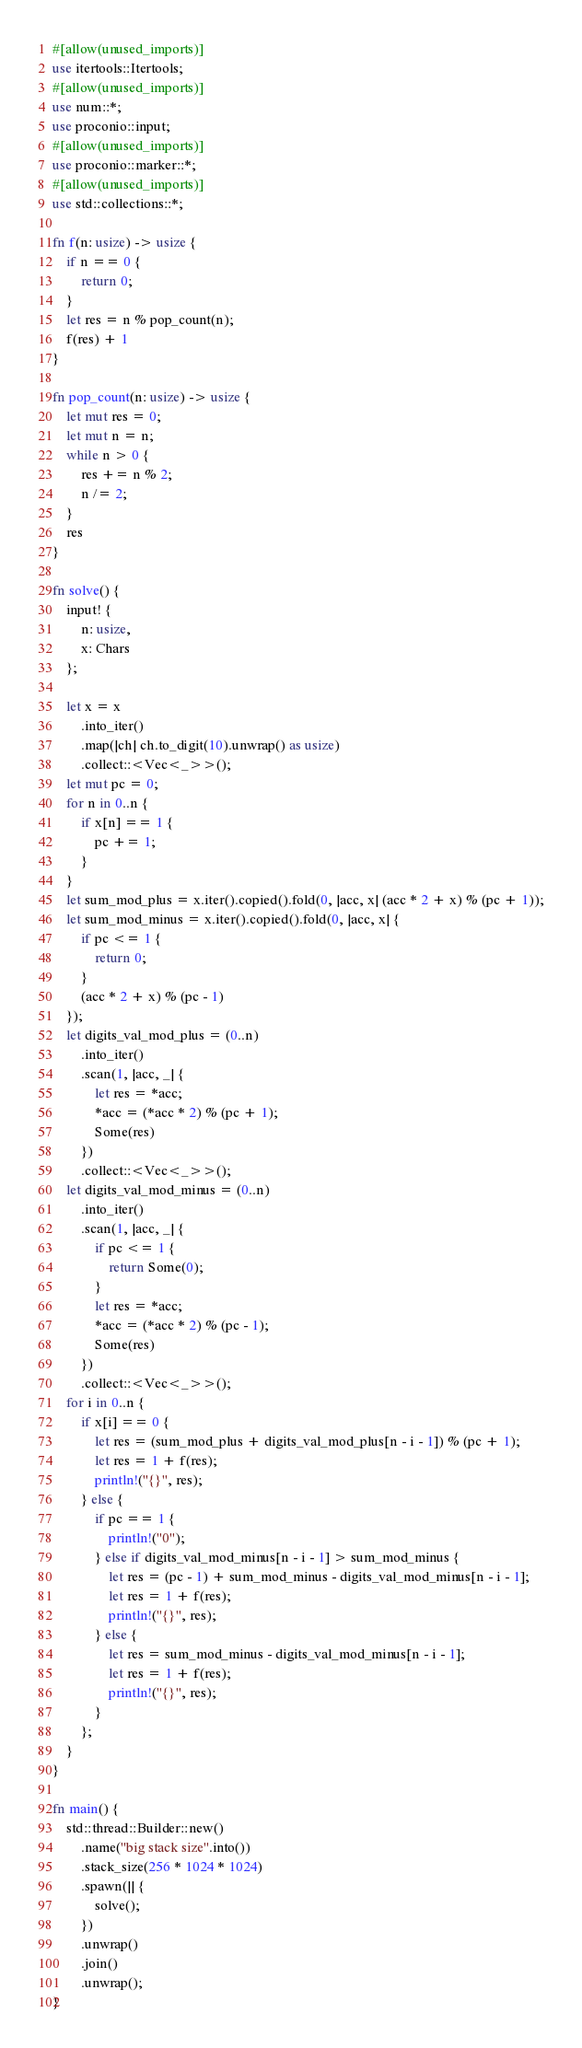<code> <loc_0><loc_0><loc_500><loc_500><_Rust_>#[allow(unused_imports)]
use itertools::Itertools;
#[allow(unused_imports)]
use num::*;
use proconio::input;
#[allow(unused_imports)]
use proconio::marker::*;
#[allow(unused_imports)]
use std::collections::*;

fn f(n: usize) -> usize {
    if n == 0 {
        return 0;
    }
    let res = n % pop_count(n);
    f(res) + 1
}

fn pop_count(n: usize) -> usize {
    let mut res = 0;
    let mut n = n;
    while n > 0 {
        res += n % 2;
        n /= 2;
    }
    res
}

fn solve() {
    input! {
        n: usize,
        x: Chars
    };

    let x = x
        .into_iter()
        .map(|ch| ch.to_digit(10).unwrap() as usize)
        .collect::<Vec<_>>();
    let mut pc = 0;
    for n in 0..n {
        if x[n] == 1 {
            pc += 1;
        }
    }
    let sum_mod_plus = x.iter().copied().fold(0, |acc, x| (acc * 2 + x) % (pc + 1));
    let sum_mod_minus = x.iter().copied().fold(0, |acc, x| {
        if pc <= 1 {
            return 0;
        }
        (acc * 2 + x) % (pc - 1)
    });
    let digits_val_mod_plus = (0..n)
        .into_iter()
        .scan(1, |acc, _| {
            let res = *acc;
            *acc = (*acc * 2) % (pc + 1);
            Some(res)
        })
        .collect::<Vec<_>>();
    let digits_val_mod_minus = (0..n)
        .into_iter()
        .scan(1, |acc, _| {
            if pc <= 1 {
                return Some(0);
            }
            let res = *acc;
            *acc = (*acc * 2) % (pc - 1);
            Some(res)
        })
        .collect::<Vec<_>>();
    for i in 0..n {
        if x[i] == 0 {
            let res = (sum_mod_plus + digits_val_mod_plus[n - i - 1]) % (pc + 1);
            let res = 1 + f(res);
            println!("{}", res);
        } else {
            if pc == 1 {
                println!("0");
            } else if digits_val_mod_minus[n - i - 1] > sum_mod_minus {
                let res = (pc - 1) + sum_mod_minus - digits_val_mod_minus[n - i - 1];
                let res = 1 + f(res);
                println!("{}", res);
            } else {
                let res = sum_mod_minus - digits_val_mod_minus[n - i - 1];
                let res = 1 + f(res);
                println!("{}", res);
            }
        };
    }
}

fn main() {
    std::thread::Builder::new()
        .name("big stack size".into())
        .stack_size(256 * 1024 * 1024)
        .spawn(|| {
            solve();
        })
        .unwrap()
        .join()
        .unwrap();
}
</code> 